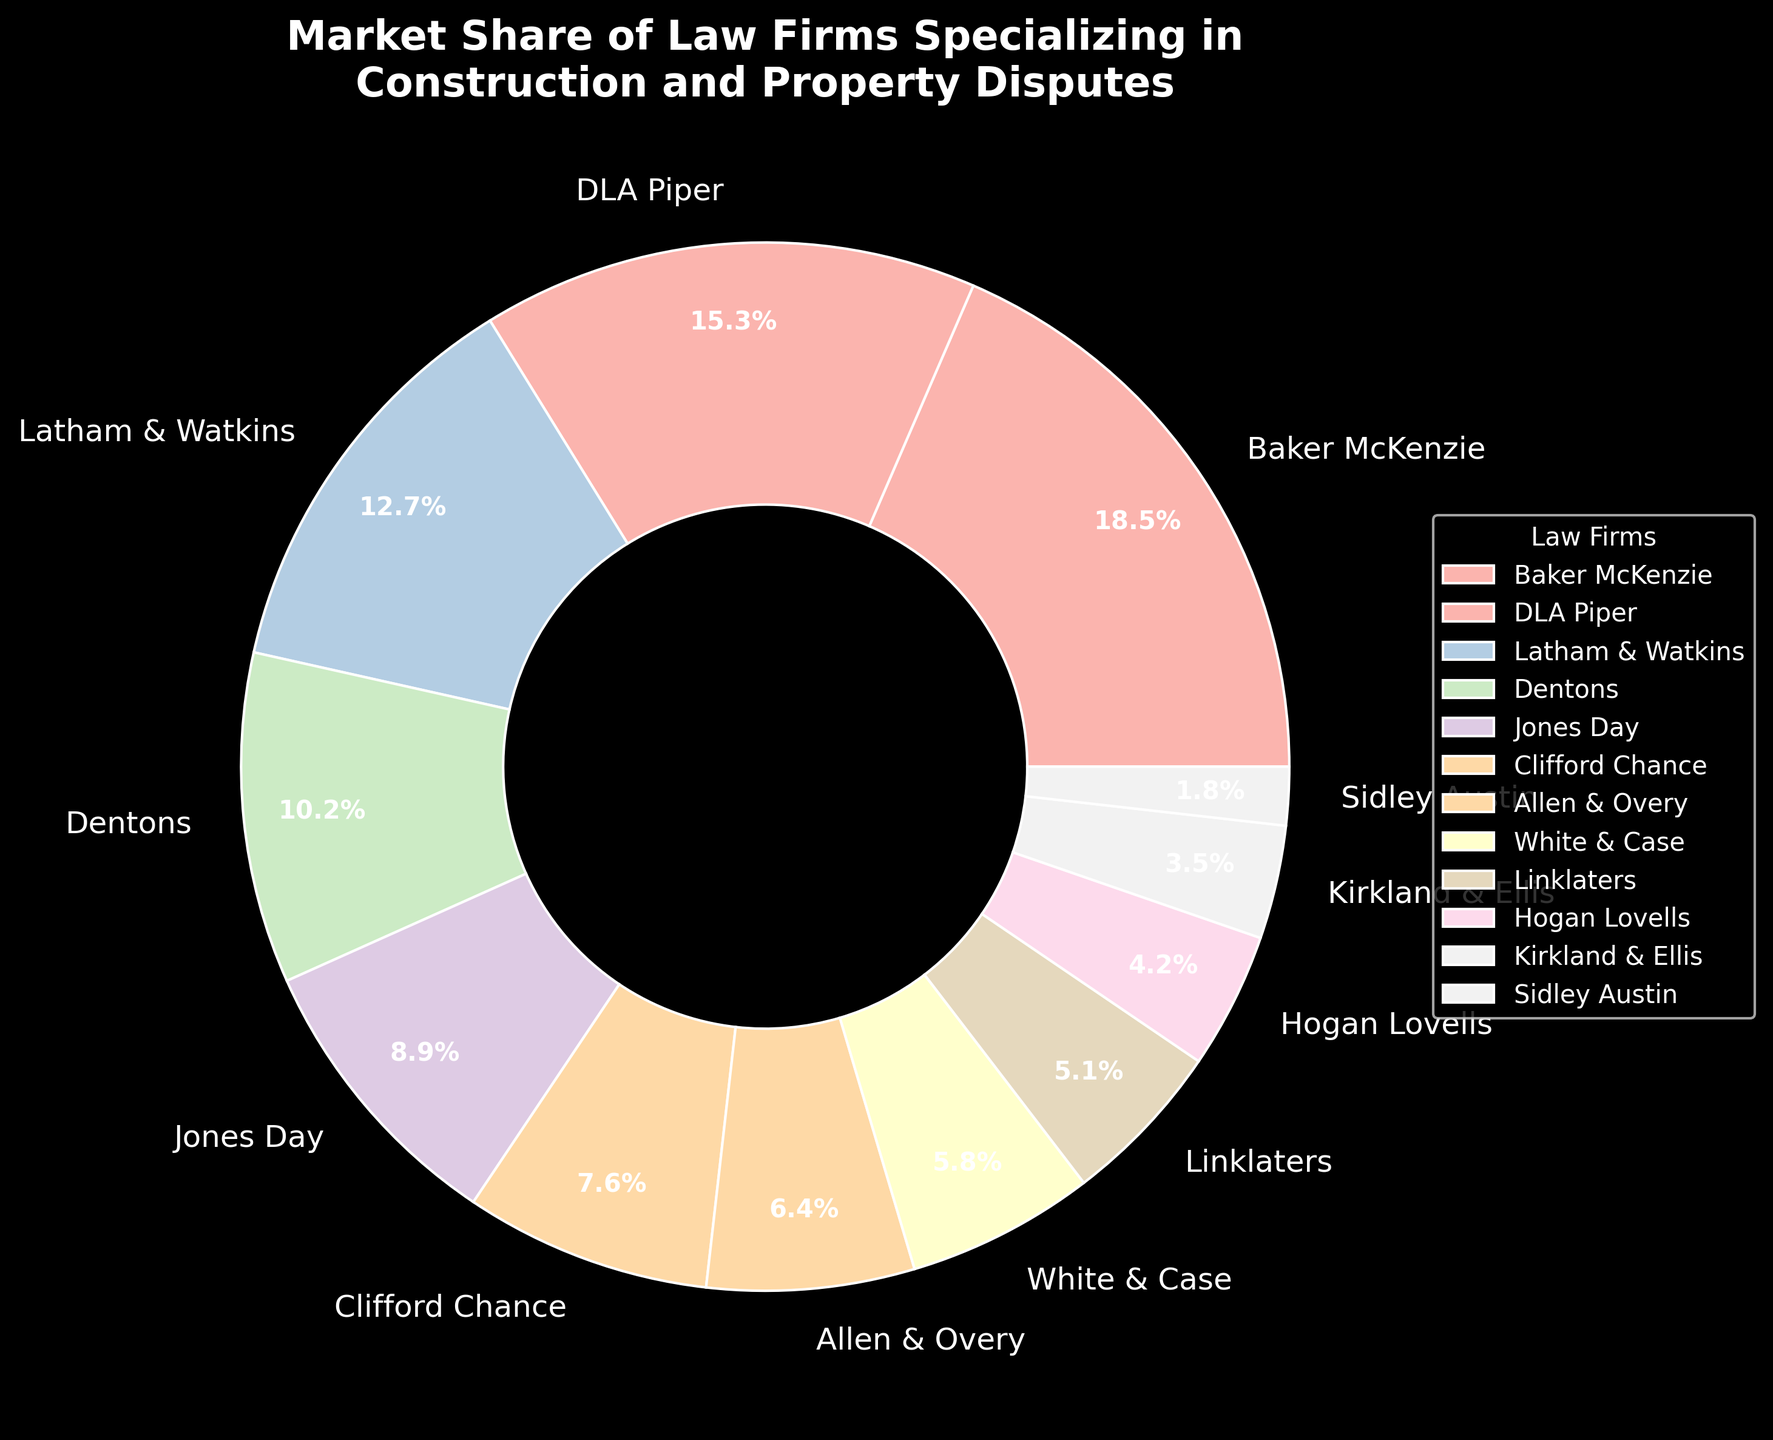Which law firm has the largest market share? The firm with the largest percentage in the pie chart has the biggest market share. Baker McKenzie has the highest share at 18.5%.
Answer: Baker McKenzie What is the combined market share of the top three law firms? Sum the market shares of Baker McKenzie (18.5%), DLA Piper (15.3%), and Latham & Watkins (12.7%). The total is 18.5 + 15.3 + 12.7 = 46.5%.
Answer: 46.5% Compare the market share of DLA Piper and Jones Day. Which one is larger and by how much? Refer to the pie chart, DLA Piper has 15.3% and Jones Day has 8.9%. The difference is 15.3 - 8.9 = 6.4%.
Answer: DLA Piper by 6.4% Which law firms have a market share less than 5%? Identify firms with market shares less than 5% from the chart. Firms are Hogan Lovells (4.2%), Kirkland & Ellis (3.5%), and Sidley Austin (1.8%).
Answer: Hogan Lovells, Kirkland & Ellis, Sidley Austin What is the average market share of all law firms? Sum the market shares of all firms and divide by the number of firms: (18.5 + 15.3 + 12.7 + 10.2 + 8.9 + 7.6 + 6.4 + 5.8 + 5.1 + 4.2 + 3.5 + 1.8) / 12. The sum is 99.0, so the average is 99.0 / 12 = 8.25%.
Answer: 8.25% How much larger is the market share of Allen & Overy compared to Kirkland & Ellis? Subtract Kirkland & Ellis's share (3.5%) from Allen & Overy's share (6.4%): 6.4 - 3.5 = 2.9%.
Answer: 2.9% Identify the law firms whose combined market share contributes to less than 20% of the market. Add up the market shares starting from the smallest until the total is less than 20%: Sidley Austin (1.8%) + Kirkland & Ellis (3.5%) + Hogan Lovells (4.2%) + Linklaters (5.1%) = 14.6%. Including White & Case (5.8%) gets 20.4%, so only up to Linklaters.
Answer: Sidley Austin, Kirkland & Ellis, Hogan Lovells, Linklaters Which law firms have market shares between 5% and 10%? Identify firms with market shares within the range from the chart: Jones Day (8.9%), Clifford Chance (7.6%), Allen & Overy (6.4%), and White & Case (5.8%).
Answer: Jones Day, Clifford Chance, Allen & Overy, White & Case 